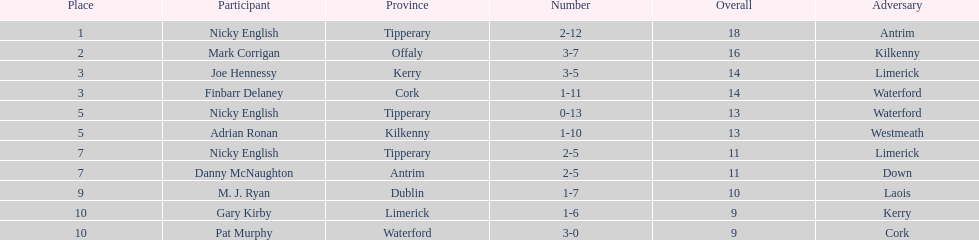What was the average of the totals of nicky english and mark corrigan? 17. 